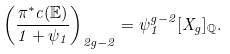Convert formula to latex. <formula><loc_0><loc_0><loc_500><loc_500>\left ( \frac { \pi ^ { * } c ( \mathbb { E } ) } { 1 + \psi _ { 1 } } \right ) _ { 2 g - 2 } = \psi _ { 1 } ^ { g - 2 } [ X _ { g } ] _ { \mathbb { Q } } .</formula> 